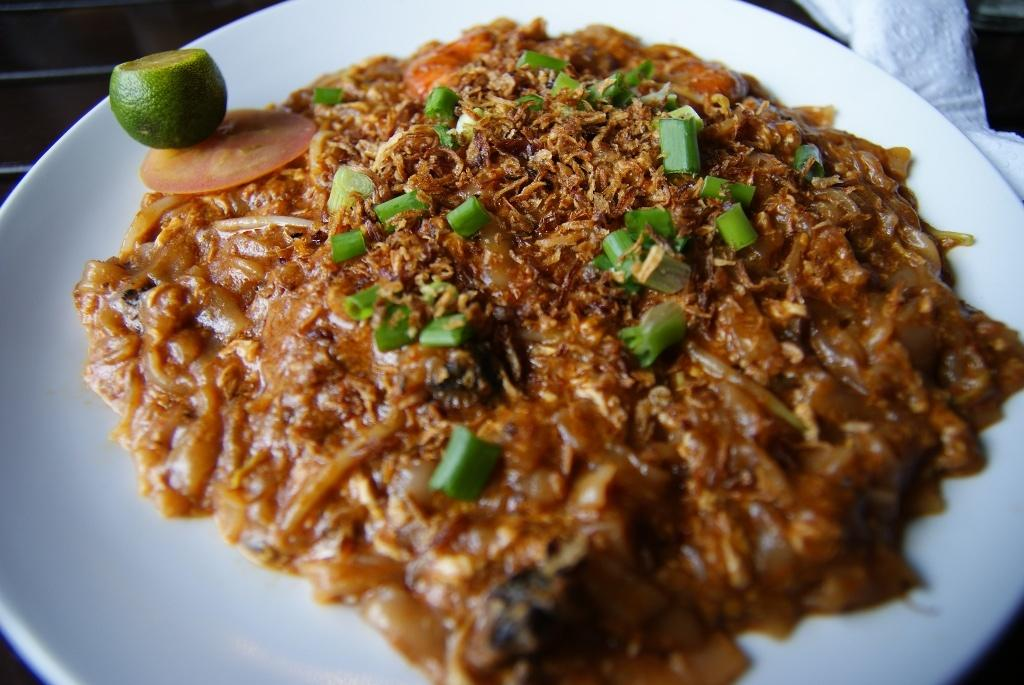What is the main food item on the plate in the image? There is a food item on a plate in the image, but the specific type of food cannot be determined from the provided facts. What other items are on the plate besides the main food item? There is a slice of tomato and a slice of lemon on the plate. How many sheep can be seen grazing in the background of the image? There are no sheep present in the image; it only features a plate with a food item, a slice of tomato, and a slice of lemon. 